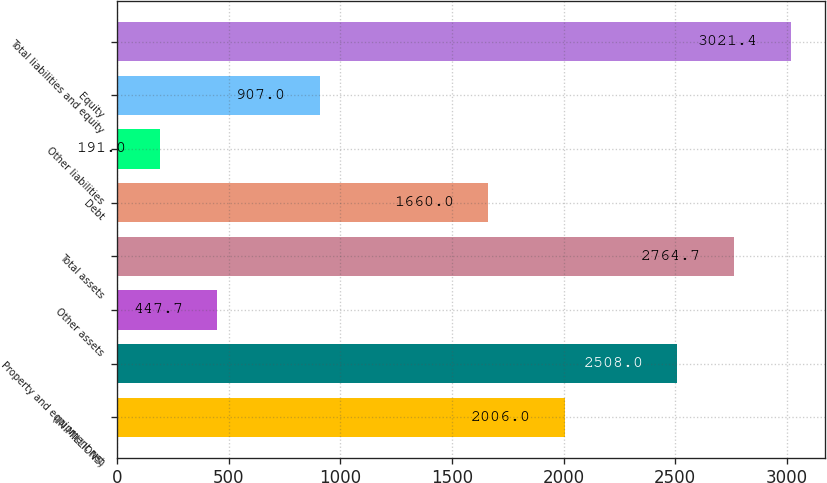Convert chart to OTSL. <chart><loc_0><loc_0><loc_500><loc_500><bar_chart><fcel>(IN MILLIONS)<fcel>Property and equipment net<fcel>Other assets<fcel>Total assets<fcel>Debt<fcel>Other liabilities<fcel>Equity<fcel>Total liabilities and equity<nl><fcel>2006<fcel>2508<fcel>447.7<fcel>2764.7<fcel>1660<fcel>191<fcel>907<fcel>3021.4<nl></chart> 